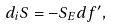Convert formula to latex. <formula><loc_0><loc_0><loc_500><loc_500>d _ { i } S = - S _ { E } d f ^ { \prime } ,</formula> 